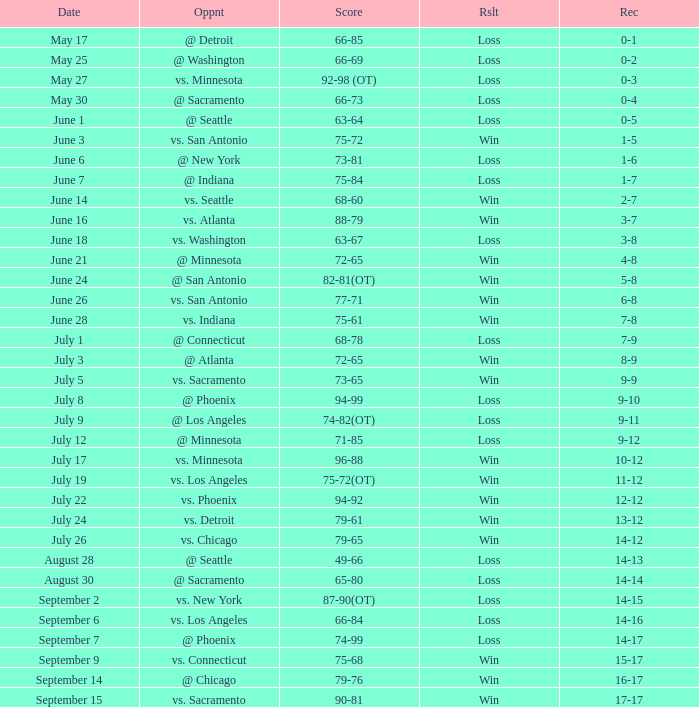What is the Record on July 12? 9-12. Help me parse the entirety of this table. {'header': ['Date', 'Oppnt', 'Score', 'Rslt', 'Rec'], 'rows': [['May 17', '@ Detroit', '66-85', 'Loss', '0-1'], ['May 25', '@ Washington', '66-69', 'Loss', '0-2'], ['May 27', 'vs. Minnesota', '92-98 (OT)', 'Loss', '0-3'], ['May 30', '@ Sacramento', '66-73', 'Loss', '0-4'], ['June 1', '@ Seattle', '63-64', 'Loss', '0-5'], ['June 3', 'vs. San Antonio', '75-72', 'Win', '1-5'], ['June 6', '@ New York', '73-81', 'Loss', '1-6'], ['June 7', '@ Indiana', '75-84', 'Loss', '1-7'], ['June 14', 'vs. Seattle', '68-60', 'Win', '2-7'], ['June 16', 'vs. Atlanta', '88-79', 'Win', '3-7'], ['June 18', 'vs. Washington', '63-67', 'Loss', '3-8'], ['June 21', '@ Minnesota', '72-65', 'Win', '4-8'], ['June 24', '@ San Antonio', '82-81(OT)', 'Win', '5-8'], ['June 26', 'vs. San Antonio', '77-71', 'Win', '6-8'], ['June 28', 'vs. Indiana', '75-61', 'Win', '7-8'], ['July 1', '@ Connecticut', '68-78', 'Loss', '7-9'], ['July 3', '@ Atlanta', '72-65', 'Win', '8-9'], ['July 5', 'vs. Sacramento', '73-65', 'Win', '9-9'], ['July 8', '@ Phoenix', '94-99', 'Loss', '9-10'], ['July 9', '@ Los Angeles', '74-82(OT)', 'Loss', '9-11'], ['July 12', '@ Minnesota', '71-85', 'Loss', '9-12'], ['July 17', 'vs. Minnesota', '96-88', 'Win', '10-12'], ['July 19', 'vs. Los Angeles', '75-72(OT)', 'Win', '11-12'], ['July 22', 'vs. Phoenix', '94-92', 'Win', '12-12'], ['July 24', 'vs. Detroit', '79-61', 'Win', '13-12'], ['July 26', 'vs. Chicago', '79-65', 'Win', '14-12'], ['August 28', '@ Seattle', '49-66', 'Loss', '14-13'], ['August 30', '@ Sacramento', '65-80', 'Loss', '14-14'], ['September 2', 'vs. New York', '87-90(OT)', 'Loss', '14-15'], ['September 6', 'vs. Los Angeles', '66-84', 'Loss', '14-16'], ['September 7', '@ Phoenix', '74-99', 'Loss', '14-17'], ['September 9', 'vs. Connecticut', '75-68', 'Win', '15-17'], ['September 14', '@ Chicago', '79-76', 'Win', '16-17'], ['September 15', 'vs. Sacramento', '90-81', 'Win', '17-17']]} 